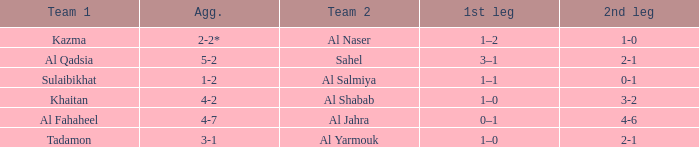What is the 1st leg of the Al Fahaheel Team 1? 0–1. 